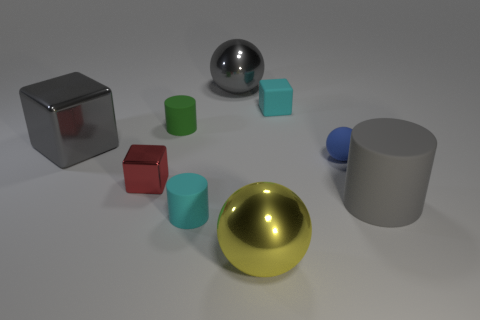The blue object that is the same shape as the yellow metallic object is what size?
Provide a short and direct response. Small. Is the small rubber block the same color as the tiny shiny thing?
Make the answer very short. No. What number of other things are there of the same material as the cyan cube
Ensure brevity in your answer.  4. Is the number of small blue balls in front of the red metallic block the same as the number of small rubber cylinders?
Make the answer very short. No. Is the size of the cyan matte thing to the left of the yellow sphere the same as the large rubber thing?
Your answer should be compact. No. What number of cyan cubes are in front of the yellow object?
Give a very brief answer. 0. What material is the large gray thing that is both to the right of the red shiny thing and behind the tiny red thing?
Ensure brevity in your answer.  Metal. What number of large objects are cyan metallic cylinders or yellow objects?
Ensure brevity in your answer.  1. What size is the cyan cube?
Provide a succinct answer. Small. What is the shape of the big yellow object?
Provide a succinct answer. Sphere. 